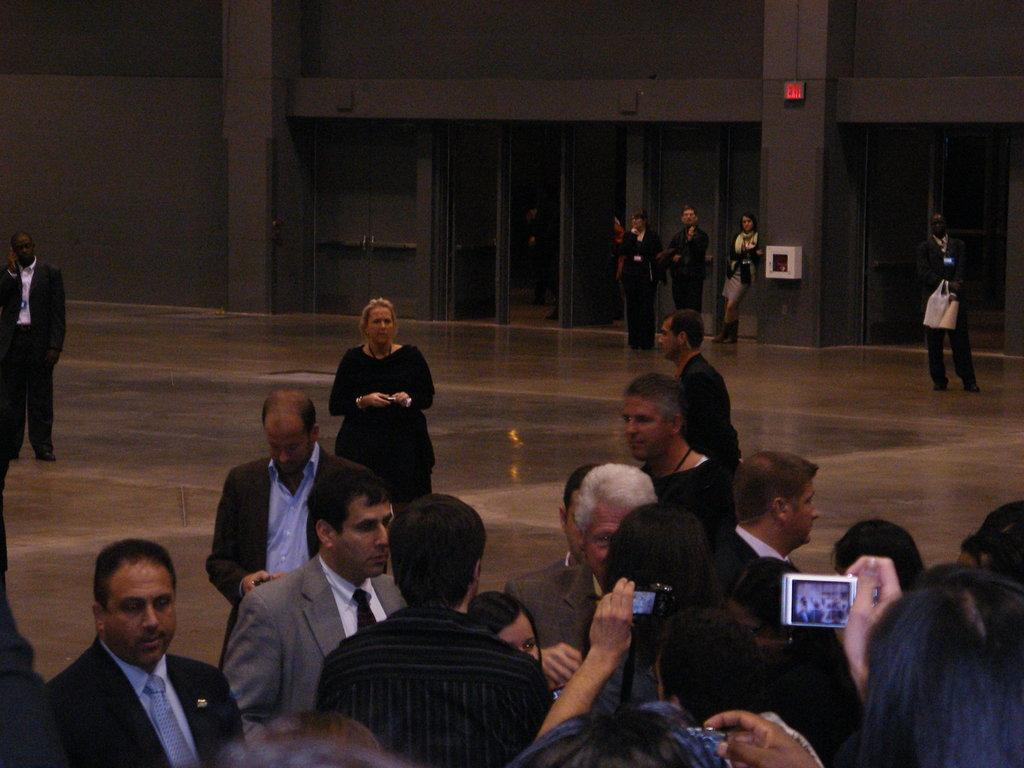What can be seen in the image? There are people standing in the image. Where are the people standing? The people are standing on the floor. What can be seen in the background of the image? There are doors and a wall in the background of the image. What is visible at the bottom of the image? The floor is visible at the bottom of the image. What riddle is being solved by the people in the image? There is no riddle being solved in the image; it simply shows people standing on the floor. Did an earthquake occur in the image? There is no indication of an earthquake in the image; the people are standing still on the floor. 